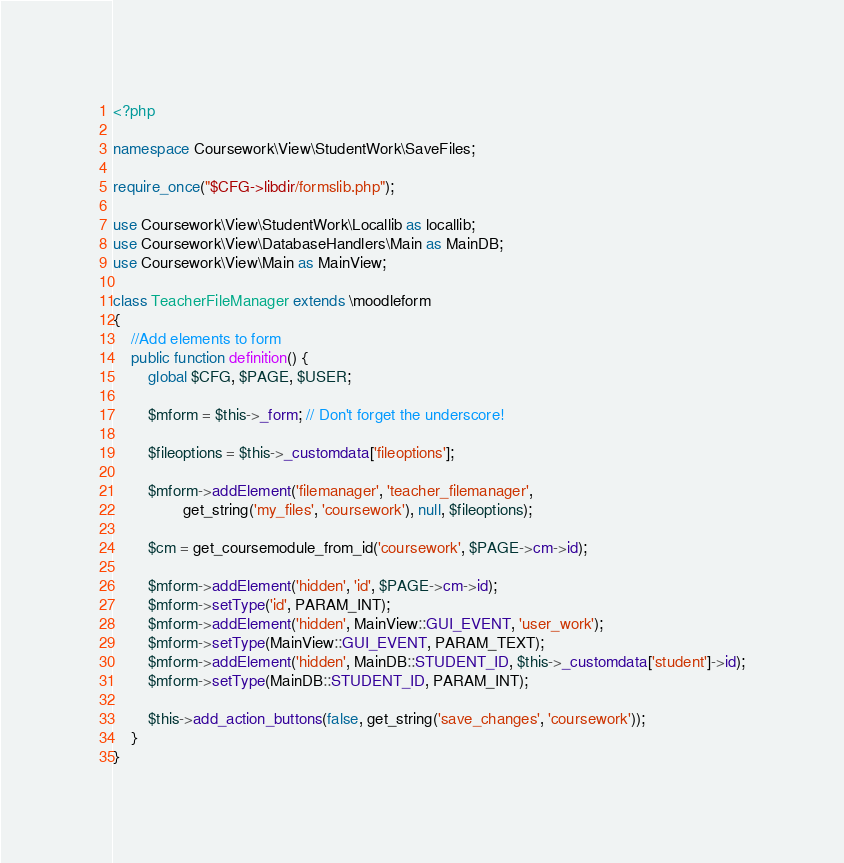Convert code to text. <code><loc_0><loc_0><loc_500><loc_500><_PHP_><?php

namespace Coursework\View\StudentWork\SaveFiles;

require_once("$CFG->libdir/formslib.php");

use Coursework\View\StudentWork\Locallib as locallib;
use Coursework\View\DatabaseHandlers\Main as MainDB;
use Coursework\View\Main as MainView;

class TeacherFileManager extends \moodleform 
{
    //Add elements to form
    public function definition() {
        global $CFG, $PAGE, $USER;
 
        $mform = $this->_form; // Don't forget the underscore! 

        $fileoptions = $this->_customdata['fileoptions'];

        $mform->addElement('filemanager', 'teacher_filemanager',
                get_string('my_files', 'coursework'), null, $fileoptions);
        
        $cm = get_coursemodule_from_id('coursework', $PAGE->cm->id);

        $mform->addElement('hidden', 'id', $PAGE->cm->id);
        $mform->setType('id', PARAM_INT);
        $mform->addElement('hidden', MainView::GUI_EVENT, 'user_work');
        $mform->setType(MainView::GUI_EVENT, PARAM_TEXT);
        $mform->addElement('hidden', MainDB::STUDENT_ID, $this->_customdata['student']->id);
        $mform->setType(MainDB::STUDENT_ID, PARAM_INT);

        $this->add_action_buttons(false, get_string('save_changes', 'coursework'));
    }
}</code> 